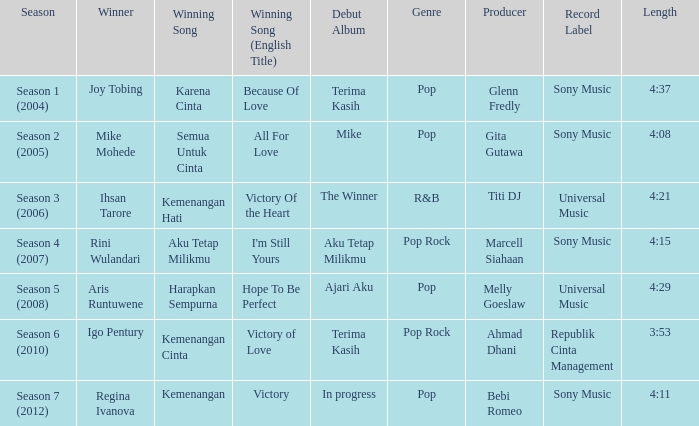Who won with the song kemenangan cinta? Igo Pentury. 